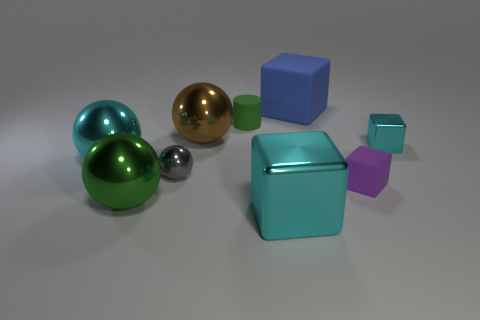What materials do the objects seem to be made from, judging by their appearance? The objects present varying appearances which indicate different materials. The reflective spheres suggest a metallic construction, possibly steel or aluminum, while the matte surfaces of the cubes could imply a plastic or painted material. The sheen and color of the large brown object in the back give the impression of a wooden texture. 